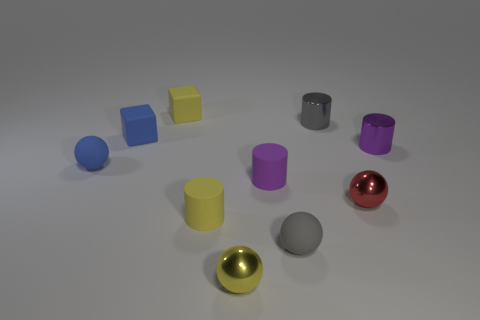Subtract all yellow cubes. How many cubes are left? 1 Subtract all small blue balls. How many balls are left? 3 Subtract 1 balls. How many balls are left? 3 Add 1 small rubber cubes. How many small rubber cubes are left? 3 Add 1 yellow cubes. How many yellow cubes exist? 2 Subtract 0 green spheres. How many objects are left? 10 Subtract all balls. How many objects are left? 6 Subtract all cyan cylinders. Subtract all purple spheres. How many cylinders are left? 4 Subtract all green cylinders. How many red spheres are left? 1 Subtract all tiny shiny objects. Subtract all yellow objects. How many objects are left? 3 